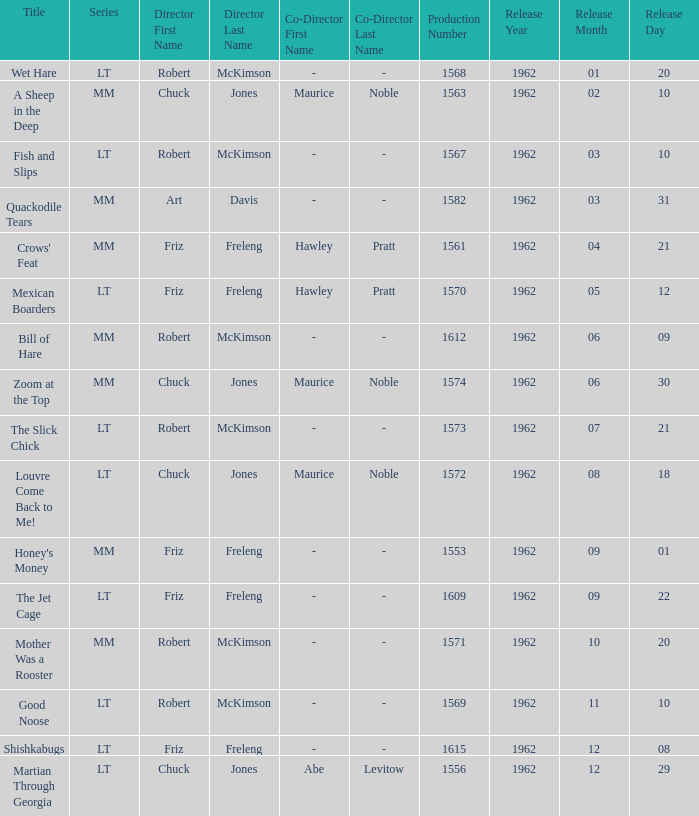I'm looking to parse the entire table for insights. Could you assist me with that? {'header': ['Title', 'Series', 'Director First Name', 'Director Last Name', 'Co-Director First Name', 'Co-Director Last Name', 'Production Number', 'Release Year', 'Release Month', 'Release Day'], 'rows': [['Wet Hare', 'LT', 'Robert', 'McKimson', '-', '-', '1568', '1962', '01', '20'], ['A Sheep in the Deep', 'MM', 'Chuck', 'Jones', 'Maurice', 'Noble', '1563', '1962', '02', '10'], ['Fish and Slips', 'LT', 'Robert', 'McKimson', '-', '-', '1567', '1962', '03', '10'], ['Quackodile Tears', 'MM', 'Art', 'Davis', '-', '-', '1582', '1962', '03', '31'], ["Crows' Feat", 'MM', 'Friz', 'Freleng', 'Hawley', 'Pratt', '1561', '1962', '04', '21'], ['Mexican Boarders', 'LT', 'Friz', 'Freleng', 'Hawley', 'Pratt', '1570', '1962', '05', '12'], ['Bill of Hare', 'MM', 'Robert', 'McKimson', '-', '-', '1612', '1962', '06', '09'], ['Zoom at the Top', 'MM', 'Chuck', 'Jones', 'Maurice', 'Noble', '1574', '1962', '06', '30'], ['The Slick Chick', 'LT', 'Robert', 'McKimson', '-', '-', '1573', '1962', '07', '21'], ['Louvre Come Back to Me!', 'LT', 'Chuck', 'Jones', 'Maurice', 'Noble', '1572', '1962', '08', '18'], ["Honey's Money", 'MM', 'Friz', 'Freleng', '-', '-', '1553', '1962', '09', '01'], ['The Jet Cage', 'LT', 'Friz', 'Freleng', '-', '-', '1609', '1962', '09', '22'], ['Mother Was a Rooster', 'MM', 'Robert', 'McKimson', '-', '-', '1571', '1962', '10', '20'], ['Good Noose', 'LT', 'Robert', 'McKimson', '-', '-', '1569', '1962', '11', '10'], ['Shishkabugs', 'LT', 'Friz', 'Freleng', '-', '-', '1615', '1962', '12', '08'], ['Martian Through Georgia', 'LT', 'Chuck', 'Jones', 'Abe', 'Levitow', '1556', '1962', '12', '29']]} What date was Wet Hare, directed by Robert McKimson, released? 1962-01-20. 